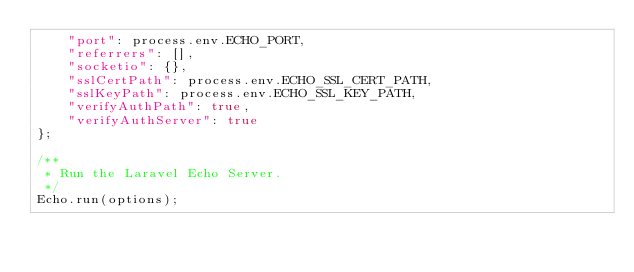Convert code to text. <code><loc_0><loc_0><loc_500><loc_500><_JavaScript_>    "port": process.env.ECHO_PORT,
    "referrers": [],
    "socketio": {},
    "sslCertPath": process.env.ECHO_SSL_CERT_PATH,
    "sslKeyPath": process.env.ECHO_SSL_KEY_PATH,
    "verifyAuthPath": true,
    "verifyAuthServer": true
};

/**
 * Run the Laravel Echo Server.
 */
Echo.run(options);
</code> 